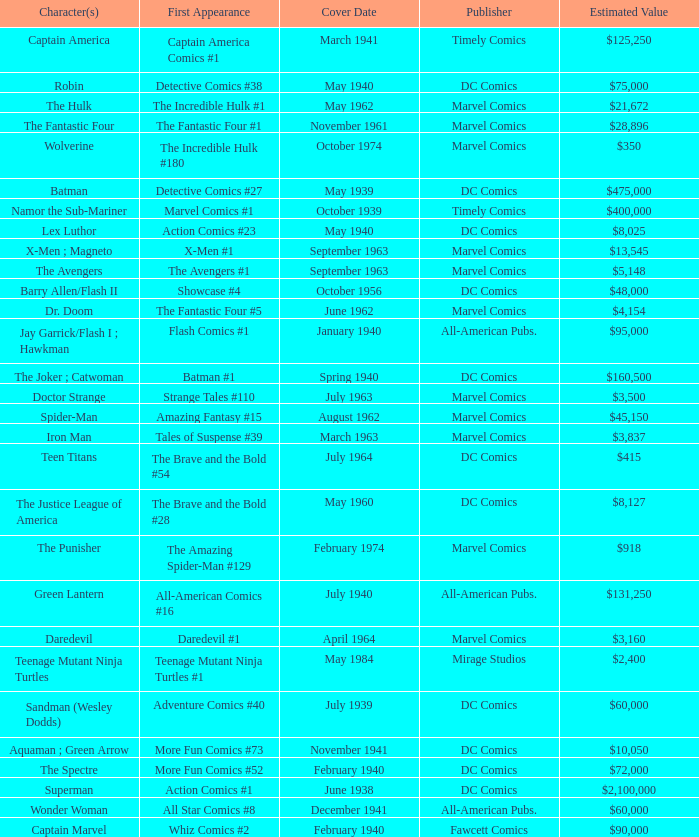Who publishes Wolverine? Marvel Comics. 